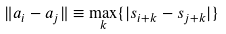<formula> <loc_0><loc_0><loc_500><loc_500>\| a _ { i } - a _ { j } \| \equiv \max _ { k } \{ | s _ { i + k } - s _ { j + k } | \}</formula> 